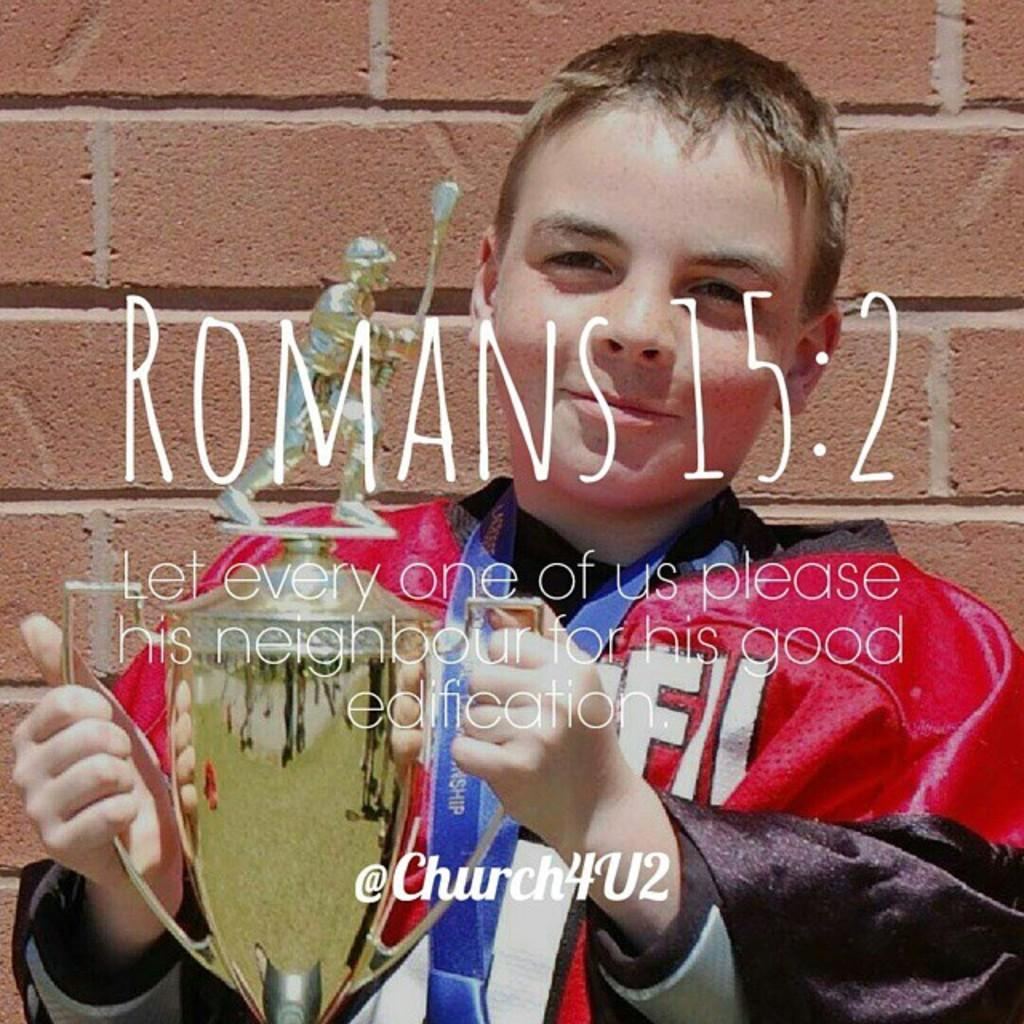Provide a one-sentence caption for the provided image. A poster of a child holding a trophy along with a biblical quote from Romans 15:2. 